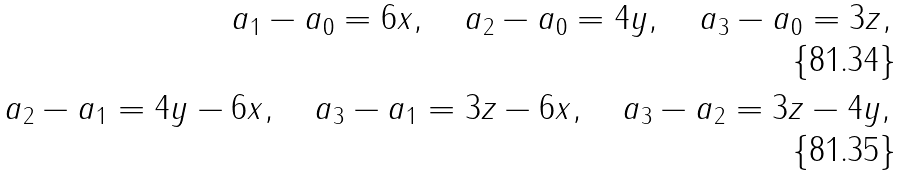<formula> <loc_0><loc_0><loc_500><loc_500>a _ { 1 } - a _ { 0 } = 6 x , \quad a _ { 2 } - a _ { 0 } = 4 y , \quad a _ { 3 } - a _ { 0 } = 3 z , \\ a _ { 2 } - a _ { 1 } = 4 y - 6 x , \quad a _ { 3 } - a _ { 1 } = 3 z - 6 x , \quad a _ { 3 } - a _ { 2 } = 3 z - 4 y ,</formula> 